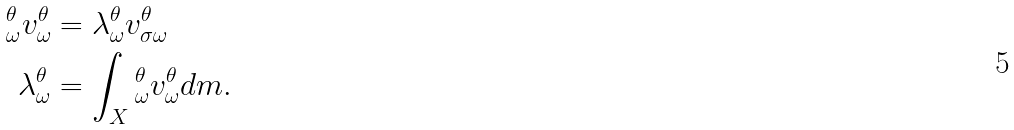<formula> <loc_0><loc_0><loc_500><loc_500>\L _ { \omega } ^ { \theta } v _ { \omega } ^ { \theta } & = \lambda _ { \omega } ^ { \theta } v _ { \sigma \omega } ^ { \theta } \\ \lambda _ { \omega } ^ { \theta } & = \int _ { X } \L _ { \omega } ^ { \theta } v _ { \omega } ^ { \theta } d m .</formula> 